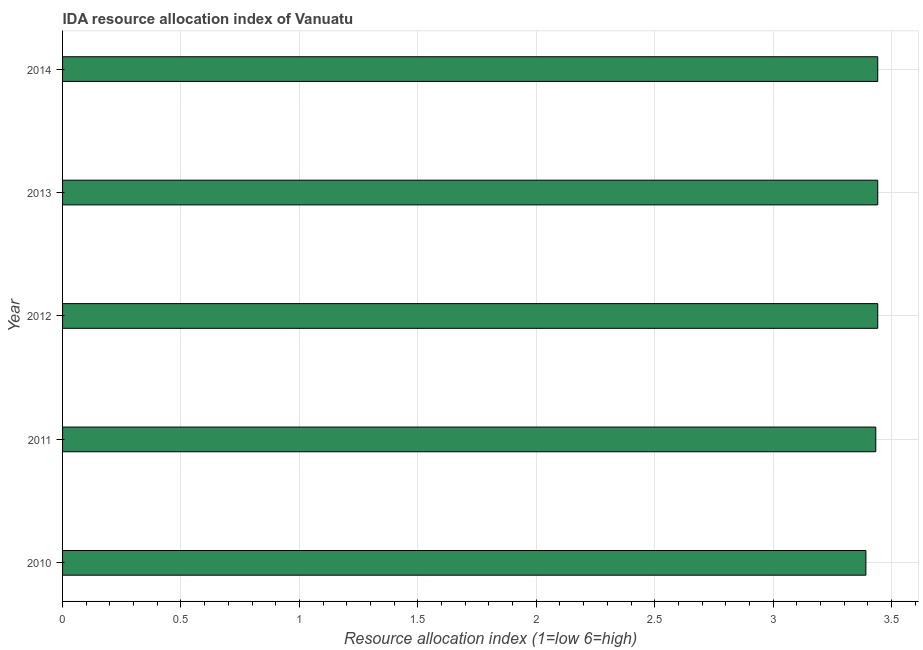Does the graph contain grids?
Keep it short and to the point. Yes. What is the title of the graph?
Give a very brief answer. IDA resource allocation index of Vanuatu. What is the label or title of the X-axis?
Keep it short and to the point. Resource allocation index (1=low 6=high). What is the label or title of the Y-axis?
Ensure brevity in your answer.  Year. What is the ida resource allocation index in 2011?
Your answer should be compact. 3.43. Across all years, what is the maximum ida resource allocation index?
Your response must be concise. 3.44. Across all years, what is the minimum ida resource allocation index?
Ensure brevity in your answer.  3.39. In which year was the ida resource allocation index minimum?
Provide a short and direct response. 2010. What is the sum of the ida resource allocation index?
Give a very brief answer. 17.15. What is the average ida resource allocation index per year?
Your answer should be compact. 3.43. What is the median ida resource allocation index?
Your answer should be very brief. 3.44. In how many years, is the ida resource allocation index greater than 1 ?
Give a very brief answer. 5. Do a majority of the years between 2014 and 2011 (inclusive) have ida resource allocation index greater than 1 ?
Keep it short and to the point. Yes. What is the ratio of the ida resource allocation index in 2010 to that in 2011?
Provide a succinct answer. 0.99. Is the difference between the ida resource allocation index in 2010 and 2012 greater than the difference between any two years?
Ensure brevity in your answer.  No. What is the difference between the highest and the second highest ida resource allocation index?
Make the answer very short. 0. Is the sum of the ida resource allocation index in 2011 and 2012 greater than the maximum ida resource allocation index across all years?
Provide a short and direct response. Yes. What is the difference between two consecutive major ticks on the X-axis?
Offer a terse response. 0.5. What is the Resource allocation index (1=low 6=high) in 2010?
Provide a succinct answer. 3.39. What is the Resource allocation index (1=low 6=high) of 2011?
Offer a terse response. 3.43. What is the Resource allocation index (1=low 6=high) in 2012?
Keep it short and to the point. 3.44. What is the Resource allocation index (1=low 6=high) of 2013?
Your answer should be very brief. 3.44. What is the Resource allocation index (1=low 6=high) of 2014?
Your response must be concise. 3.44. What is the difference between the Resource allocation index (1=low 6=high) in 2010 and 2011?
Provide a succinct answer. -0.04. What is the difference between the Resource allocation index (1=low 6=high) in 2010 and 2013?
Your response must be concise. -0.05. What is the difference between the Resource allocation index (1=low 6=high) in 2011 and 2012?
Offer a very short reply. -0.01. What is the difference between the Resource allocation index (1=low 6=high) in 2011 and 2013?
Offer a terse response. -0.01. What is the difference between the Resource allocation index (1=low 6=high) in 2011 and 2014?
Your answer should be compact. -0.01. What is the difference between the Resource allocation index (1=low 6=high) in 2012 and 2013?
Offer a terse response. 0. What is the ratio of the Resource allocation index (1=low 6=high) in 2010 to that in 2012?
Keep it short and to the point. 0.98. What is the ratio of the Resource allocation index (1=low 6=high) in 2010 to that in 2013?
Your answer should be compact. 0.98. What is the ratio of the Resource allocation index (1=low 6=high) in 2010 to that in 2014?
Keep it short and to the point. 0.98. What is the ratio of the Resource allocation index (1=low 6=high) in 2012 to that in 2013?
Ensure brevity in your answer.  1. 